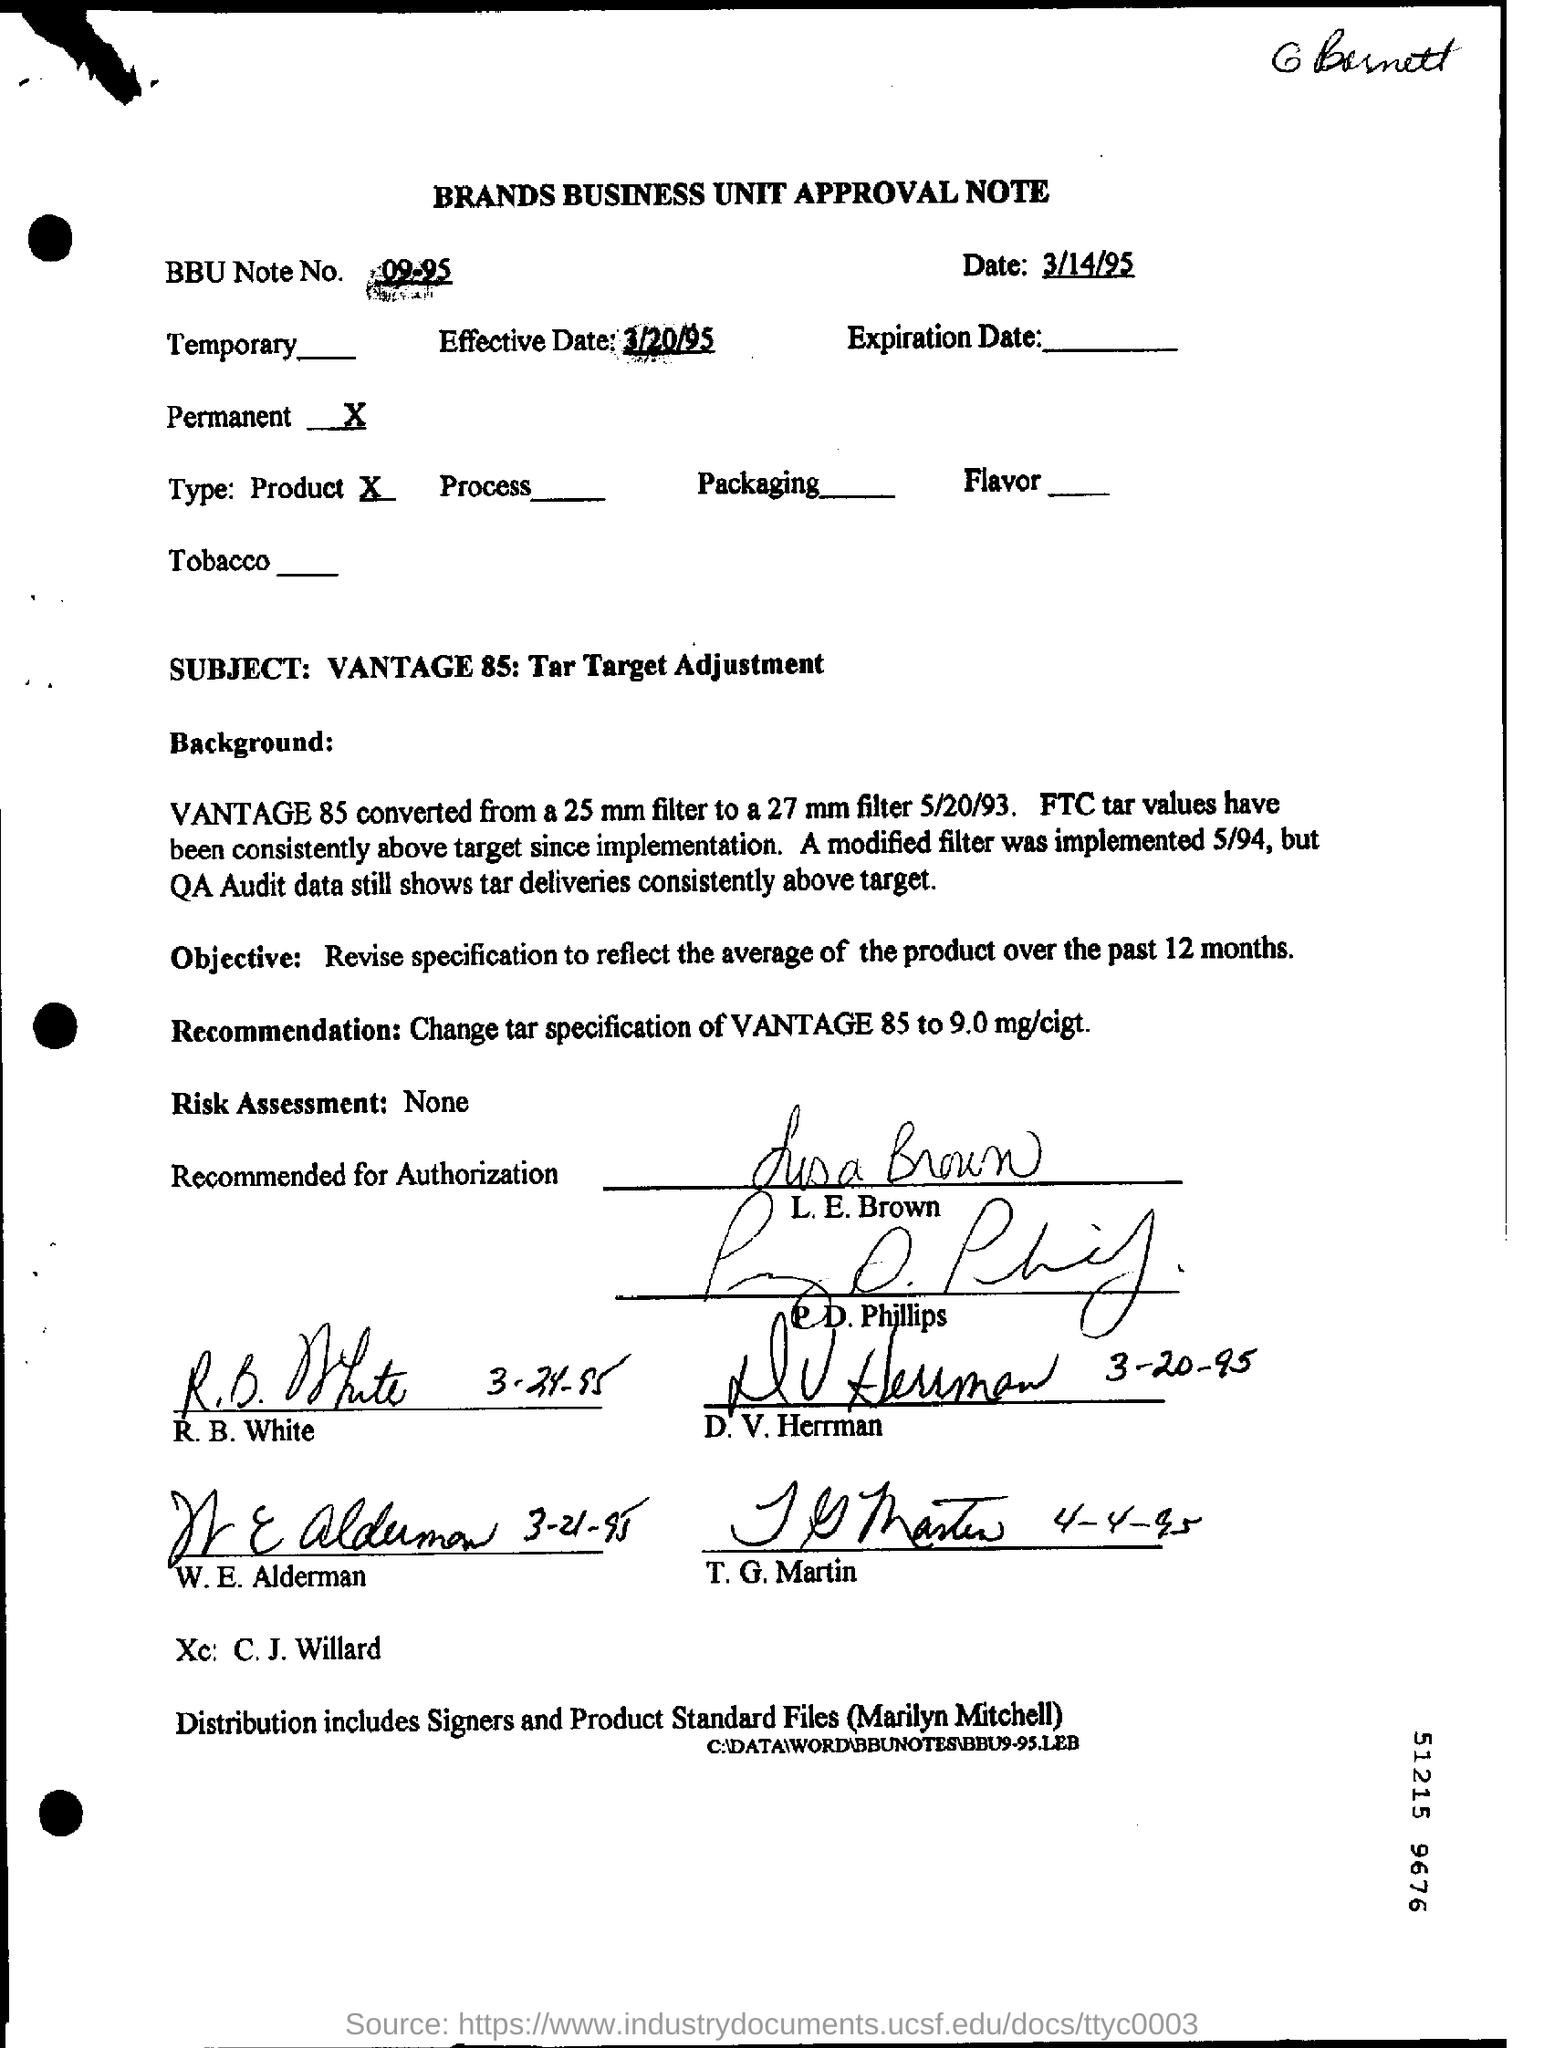Indicate a few pertinent items in this graphic. As per the form, the revision is permanent. The BBU Note No Field contains the text '09-95..'. The date mentioned at the top of the document is March 14, 1995. The effective date, which is written in the field, is March 20, 1995. 